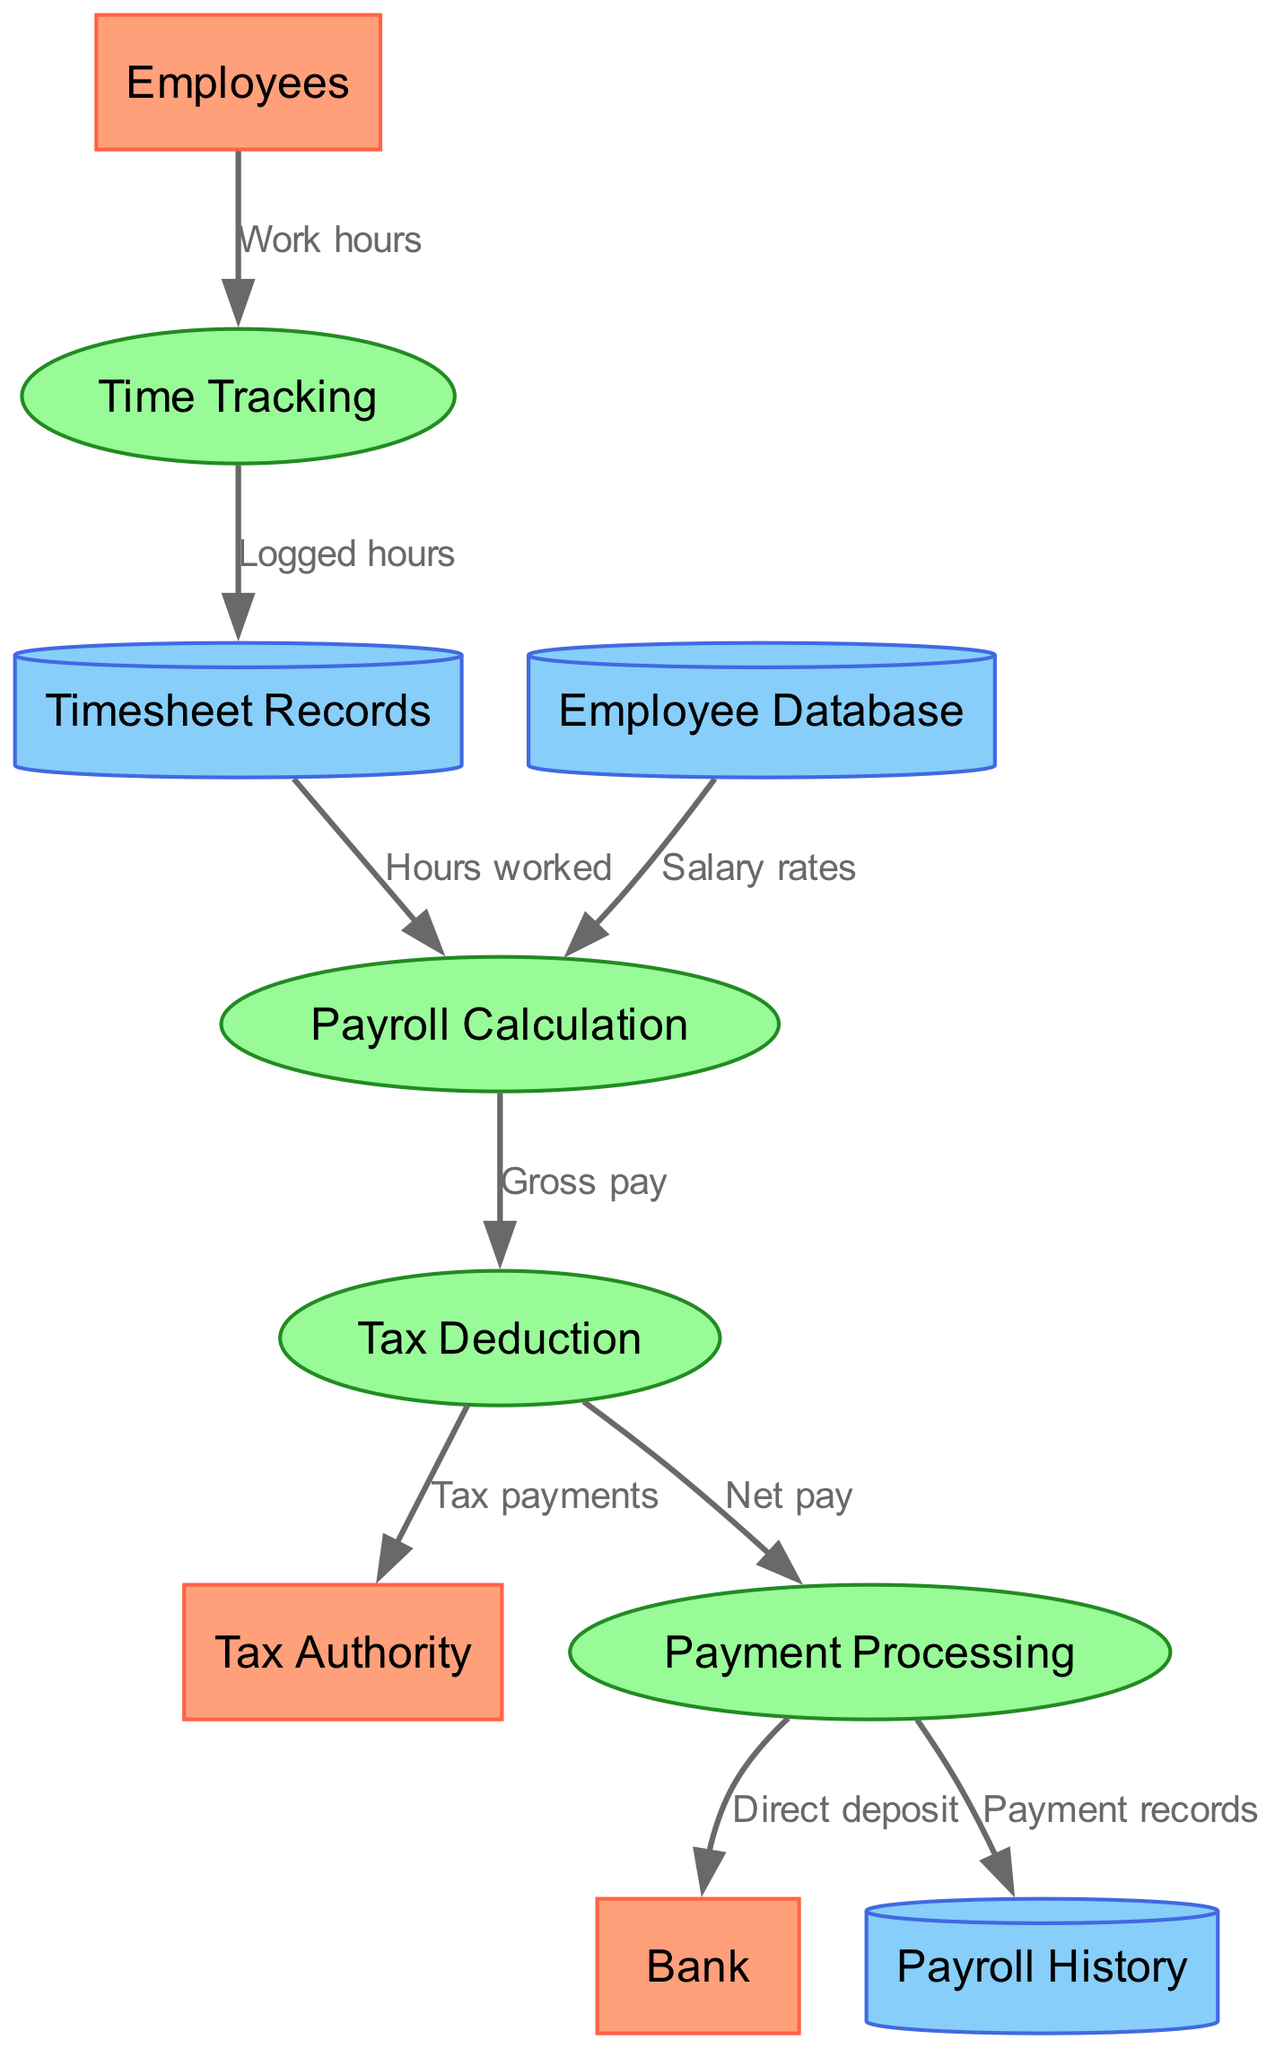What external entities are involved in the payroll process? The external entities listed in the diagram are Employees, Bank, and Tax Authority. These are the parties that interact with the payroll processing system at different stages.
Answer: Employees, Bank, Tax Authority How many processes are shown in the diagram? The diagram displays four processes: Time Tracking, Payroll Calculation, Tax Deduction, and Payment Processing. Counting these processes gives us the total number involved in the payroll system.
Answer: 4 Which process receives data from Timesheet Records? The Payroll Calculation process receives data represented as "Hours worked" from Timesheet Records. This shows the flow of logged hours to the calculation of payroll.
Answer: Payroll Calculation What is the output of the Tax Deduction process directed towards? The output of the Tax Deduction process goes towards two destinations: Payment Processing and Tax Authority. The data labeled as "Net pay" facilitates payment processing, while "Tax payments" is directed to the Tax Authority.
Answer: Payment Processing, Tax Authority From which data store does Payroll Calculation obtain salary rates? The Payroll Calculation process obtains the salary rates from the Employee Database. This is indicated in the diagram through the labeled flow between the two entities.
Answer: Employee Database What type of data flows from Payment Processing to the Bank? The type of data flowing from Payment Processing to the Bank is labeled as "Direct deposit." This indicates that the payment is transferred electronically to the bank account of the employees.
Answer: Direct deposit How does Tax Deduction process affect employee payments? The Tax Deduction process affects employee payments by calculating the "Net pay," which is the amount processed for payment. Thus, it is instrumental in determining what employees ultimately receive.
Answer: Net pay What data does Time Tracking receive from Employees? Time Tracking receives "Work hours" from Employees. This indicates that the system tracks the hours they have worked, which is fundamental for payroll calculation.
Answer: Work hours Identify the data flow that leads to Payroll History. The data flow to Payroll History is labeled as "Payment records." This flow represents the documentation of payments made to employees within the system.
Answer: Payment records 